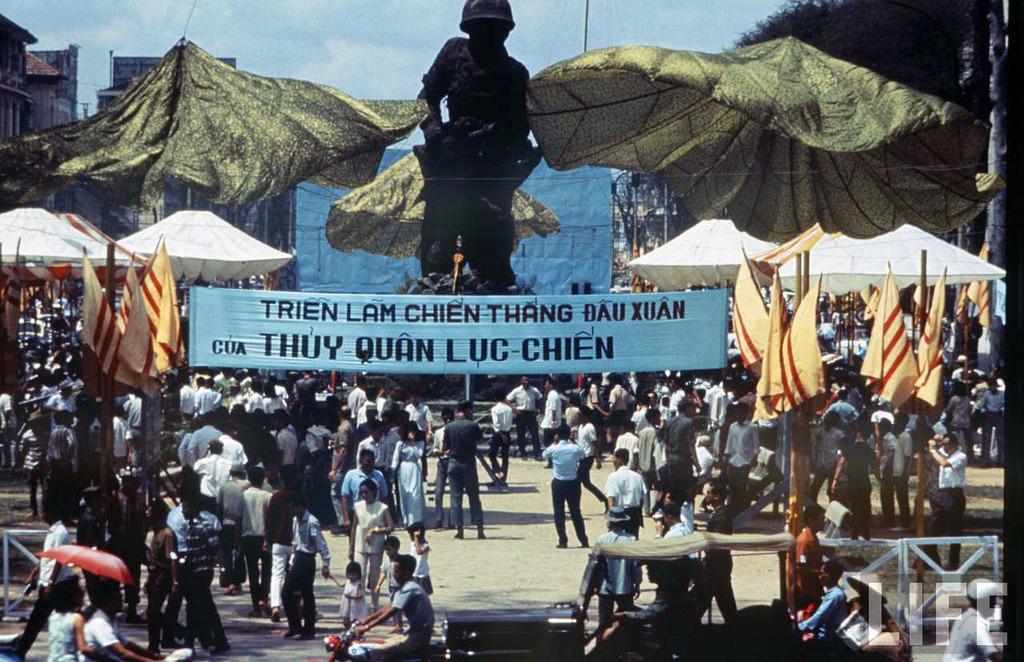In one or two sentences, can you explain what this image depicts? In this picture I can see few people are standing and I can see a banner with some text and I can see few flags and few tents and I can see buildings, trees and I can see a jeep and few people are moving on the motorcycles and I can see an umbrella and it looks like a statue in the back and I can see a blue cloudy sky. 